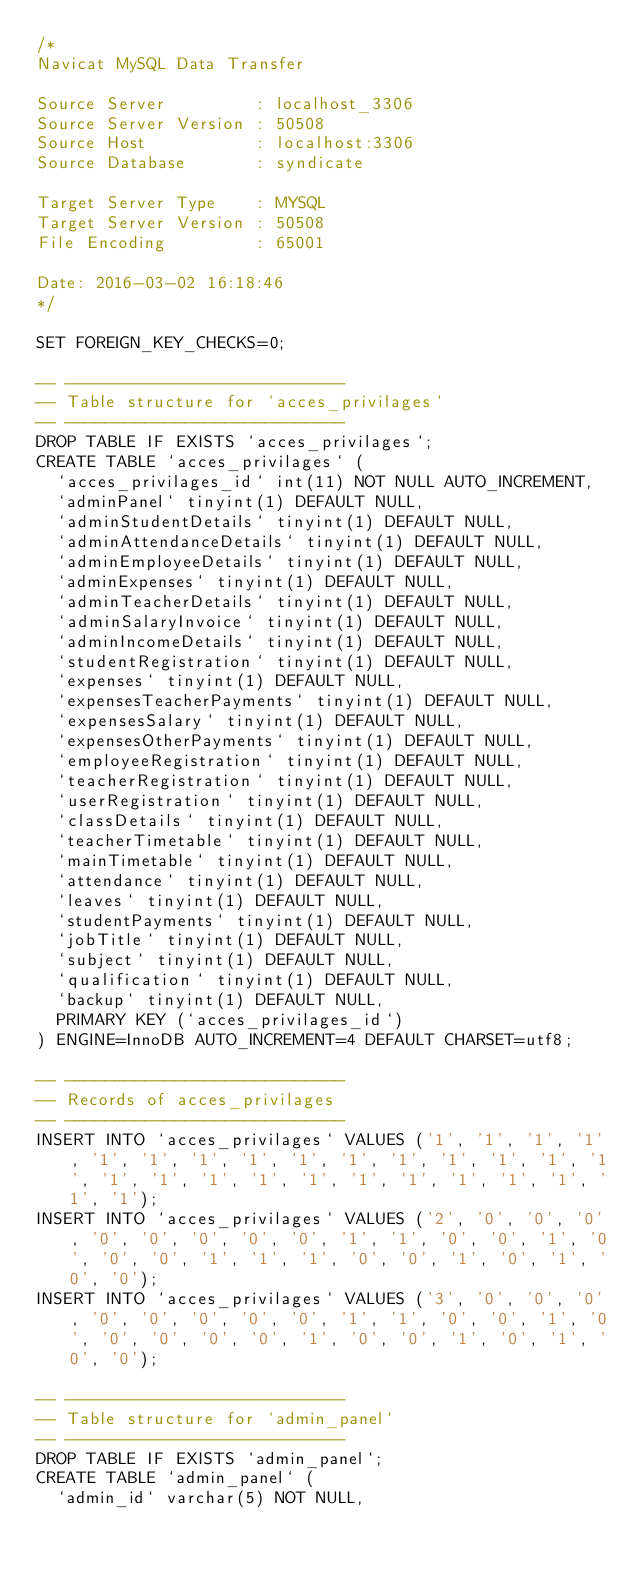<code> <loc_0><loc_0><loc_500><loc_500><_SQL_>/*
Navicat MySQL Data Transfer

Source Server         : localhost_3306
Source Server Version : 50508
Source Host           : localhost:3306
Source Database       : syndicate

Target Server Type    : MYSQL
Target Server Version : 50508
File Encoding         : 65001

Date: 2016-03-02 16:18:46
*/

SET FOREIGN_KEY_CHECKS=0;

-- ----------------------------
-- Table structure for `acces_privilages`
-- ----------------------------
DROP TABLE IF EXISTS `acces_privilages`;
CREATE TABLE `acces_privilages` (
  `acces_privilages_id` int(11) NOT NULL AUTO_INCREMENT,
  `adminPanel` tinyint(1) DEFAULT NULL,
  `adminStudentDetails` tinyint(1) DEFAULT NULL,
  `adminAttendanceDetails` tinyint(1) DEFAULT NULL,
  `adminEmployeeDetails` tinyint(1) DEFAULT NULL,
  `adminExpenses` tinyint(1) DEFAULT NULL,
  `adminTeacherDetails` tinyint(1) DEFAULT NULL,
  `adminSalaryInvoice` tinyint(1) DEFAULT NULL,
  `adminIncomeDetails` tinyint(1) DEFAULT NULL,
  `studentRegistration` tinyint(1) DEFAULT NULL,
  `expenses` tinyint(1) DEFAULT NULL,
  `expensesTeacherPayments` tinyint(1) DEFAULT NULL,
  `expensesSalary` tinyint(1) DEFAULT NULL,
  `expensesOtherPayments` tinyint(1) DEFAULT NULL,
  `employeeRegistration` tinyint(1) DEFAULT NULL,
  `teacherRegistration` tinyint(1) DEFAULT NULL,
  `userRegistration` tinyint(1) DEFAULT NULL,
  `classDetails` tinyint(1) DEFAULT NULL,
  `teacherTimetable` tinyint(1) DEFAULT NULL,
  `mainTimetable` tinyint(1) DEFAULT NULL,
  `attendance` tinyint(1) DEFAULT NULL,
  `leaves` tinyint(1) DEFAULT NULL,
  `studentPayments` tinyint(1) DEFAULT NULL,
  `jobTitle` tinyint(1) DEFAULT NULL,
  `subject` tinyint(1) DEFAULT NULL,
  `qualification` tinyint(1) DEFAULT NULL,
  `backup` tinyint(1) DEFAULT NULL,
  PRIMARY KEY (`acces_privilages_id`)
) ENGINE=InnoDB AUTO_INCREMENT=4 DEFAULT CHARSET=utf8;

-- ----------------------------
-- Records of acces_privilages
-- ----------------------------
INSERT INTO `acces_privilages` VALUES ('1', '1', '1', '1', '1', '1', '1', '1', '1', '1', '1', '1', '1', '1', '1', '1', '1', '1', '1', '1', '1', '1', '1', '1', '1', '1', '1');
INSERT INTO `acces_privilages` VALUES ('2', '0', '0', '0', '0', '0', '0', '0', '0', '1', '1', '0', '0', '1', '0', '0', '0', '1', '1', '1', '0', '0', '1', '0', '1', '0', '0');
INSERT INTO `acces_privilages` VALUES ('3', '0', '0', '0', '0', '0', '0', '0', '0', '1', '1', '0', '0', '1', '0', '0', '0', '0', '0', '1', '0', '0', '1', '0', '1', '0', '0');

-- ----------------------------
-- Table structure for `admin_panel`
-- ----------------------------
DROP TABLE IF EXISTS `admin_panel`;
CREATE TABLE `admin_panel` (
  `admin_id` varchar(5) NOT NULL,</code> 